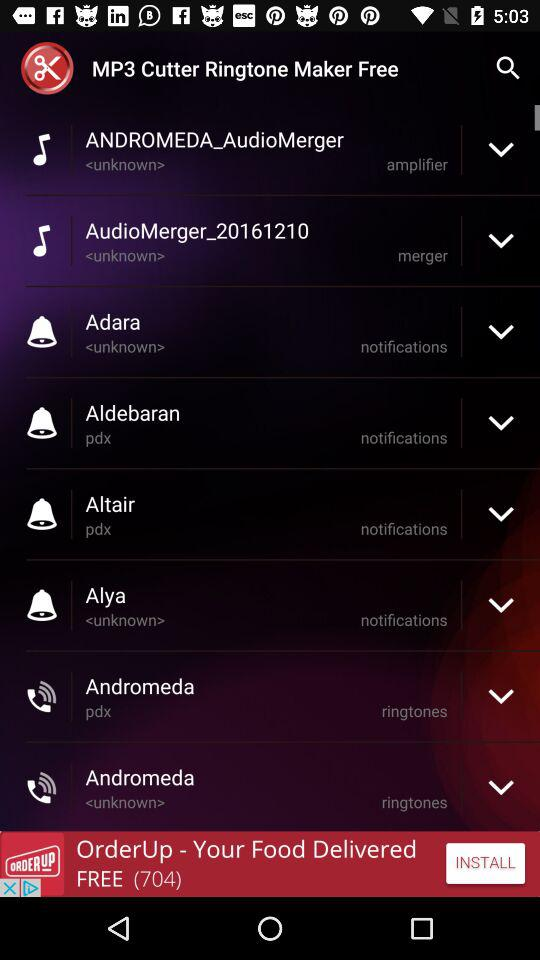What is the name of the application? The name of the application is "MP3 Cutter Ringtone Maker Free". 